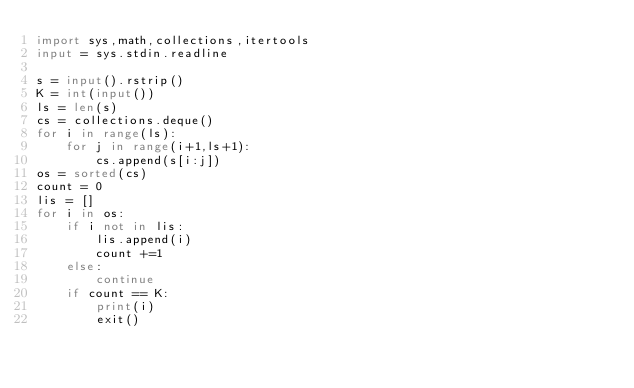<code> <loc_0><loc_0><loc_500><loc_500><_Python_>import sys,math,collections,itertools
input = sys.stdin.readline

s = input().rstrip()
K = int(input())
ls = len(s)
cs = collections.deque()
for i in range(ls):
    for j in range(i+1,ls+1):
        cs.append(s[i:j])
os = sorted(cs)
count = 0
lis = []
for i in os:
    if i not in lis:
        lis.append(i)
        count +=1
    else:
        continue
    if count == K:
        print(i)
        exit()
    </code> 